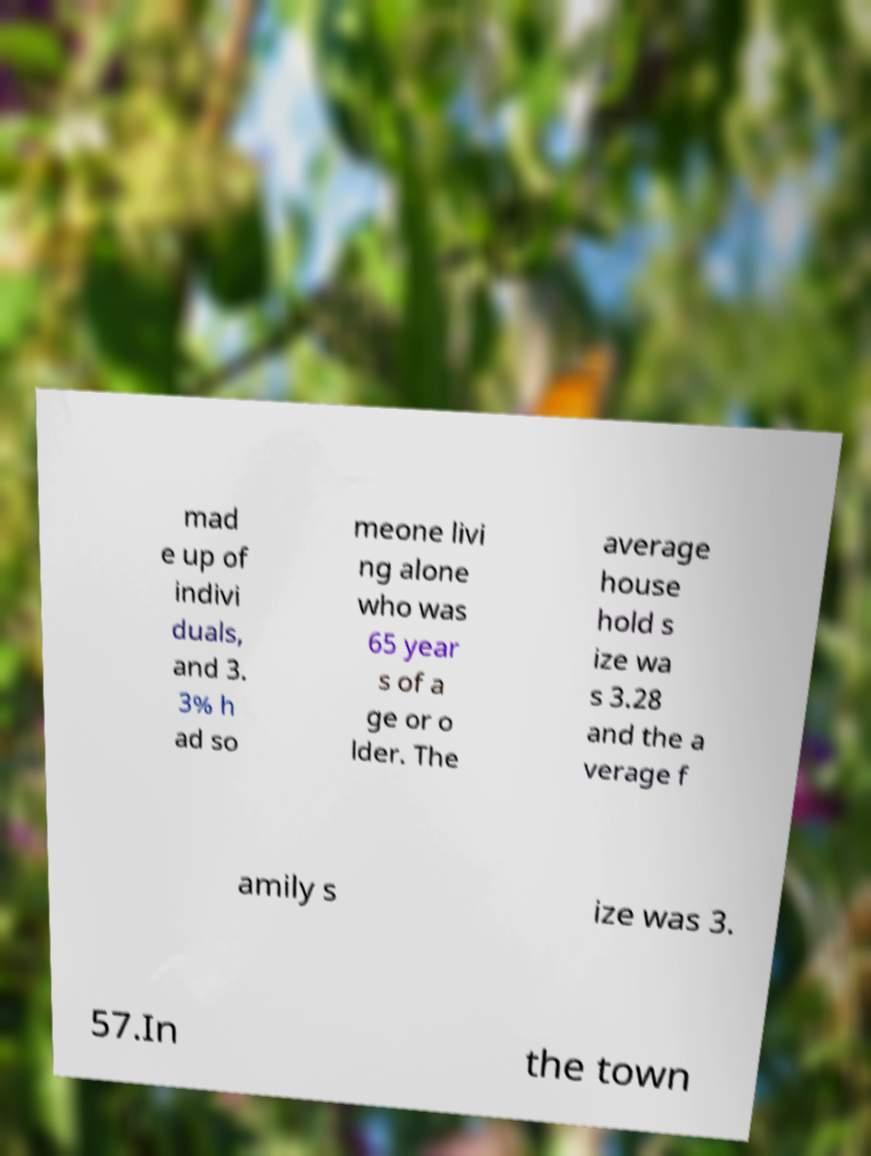For documentation purposes, I need the text within this image transcribed. Could you provide that? mad e up of indivi duals, and 3. 3% h ad so meone livi ng alone who was 65 year s of a ge or o lder. The average house hold s ize wa s 3.28 and the a verage f amily s ize was 3. 57.In the town 